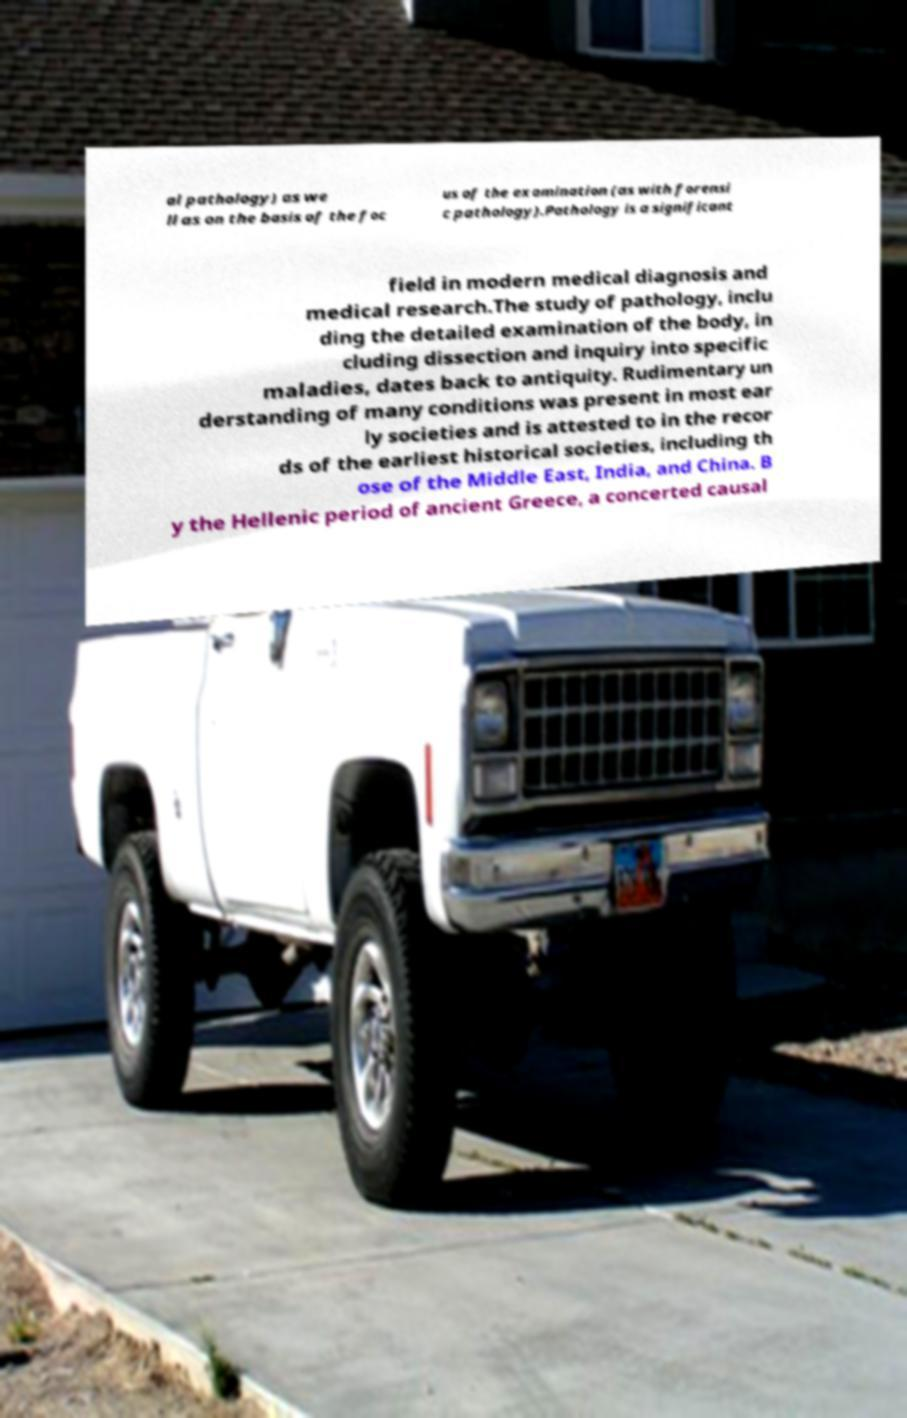Please identify and transcribe the text found in this image. al pathology) as we ll as on the basis of the foc us of the examination (as with forensi c pathology).Pathology is a significant field in modern medical diagnosis and medical research.The study of pathology, inclu ding the detailed examination of the body, in cluding dissection and inquiry into specific maladies, dates back to antiquity. Rudimentary un derstanding of many conditions was present in most ear ly societies and is attested to in the recor ds of the earliest historical societies, including th ose of the Middle East, India, and China. B y the Hellenic period of ancient Greece, a concerted causal 